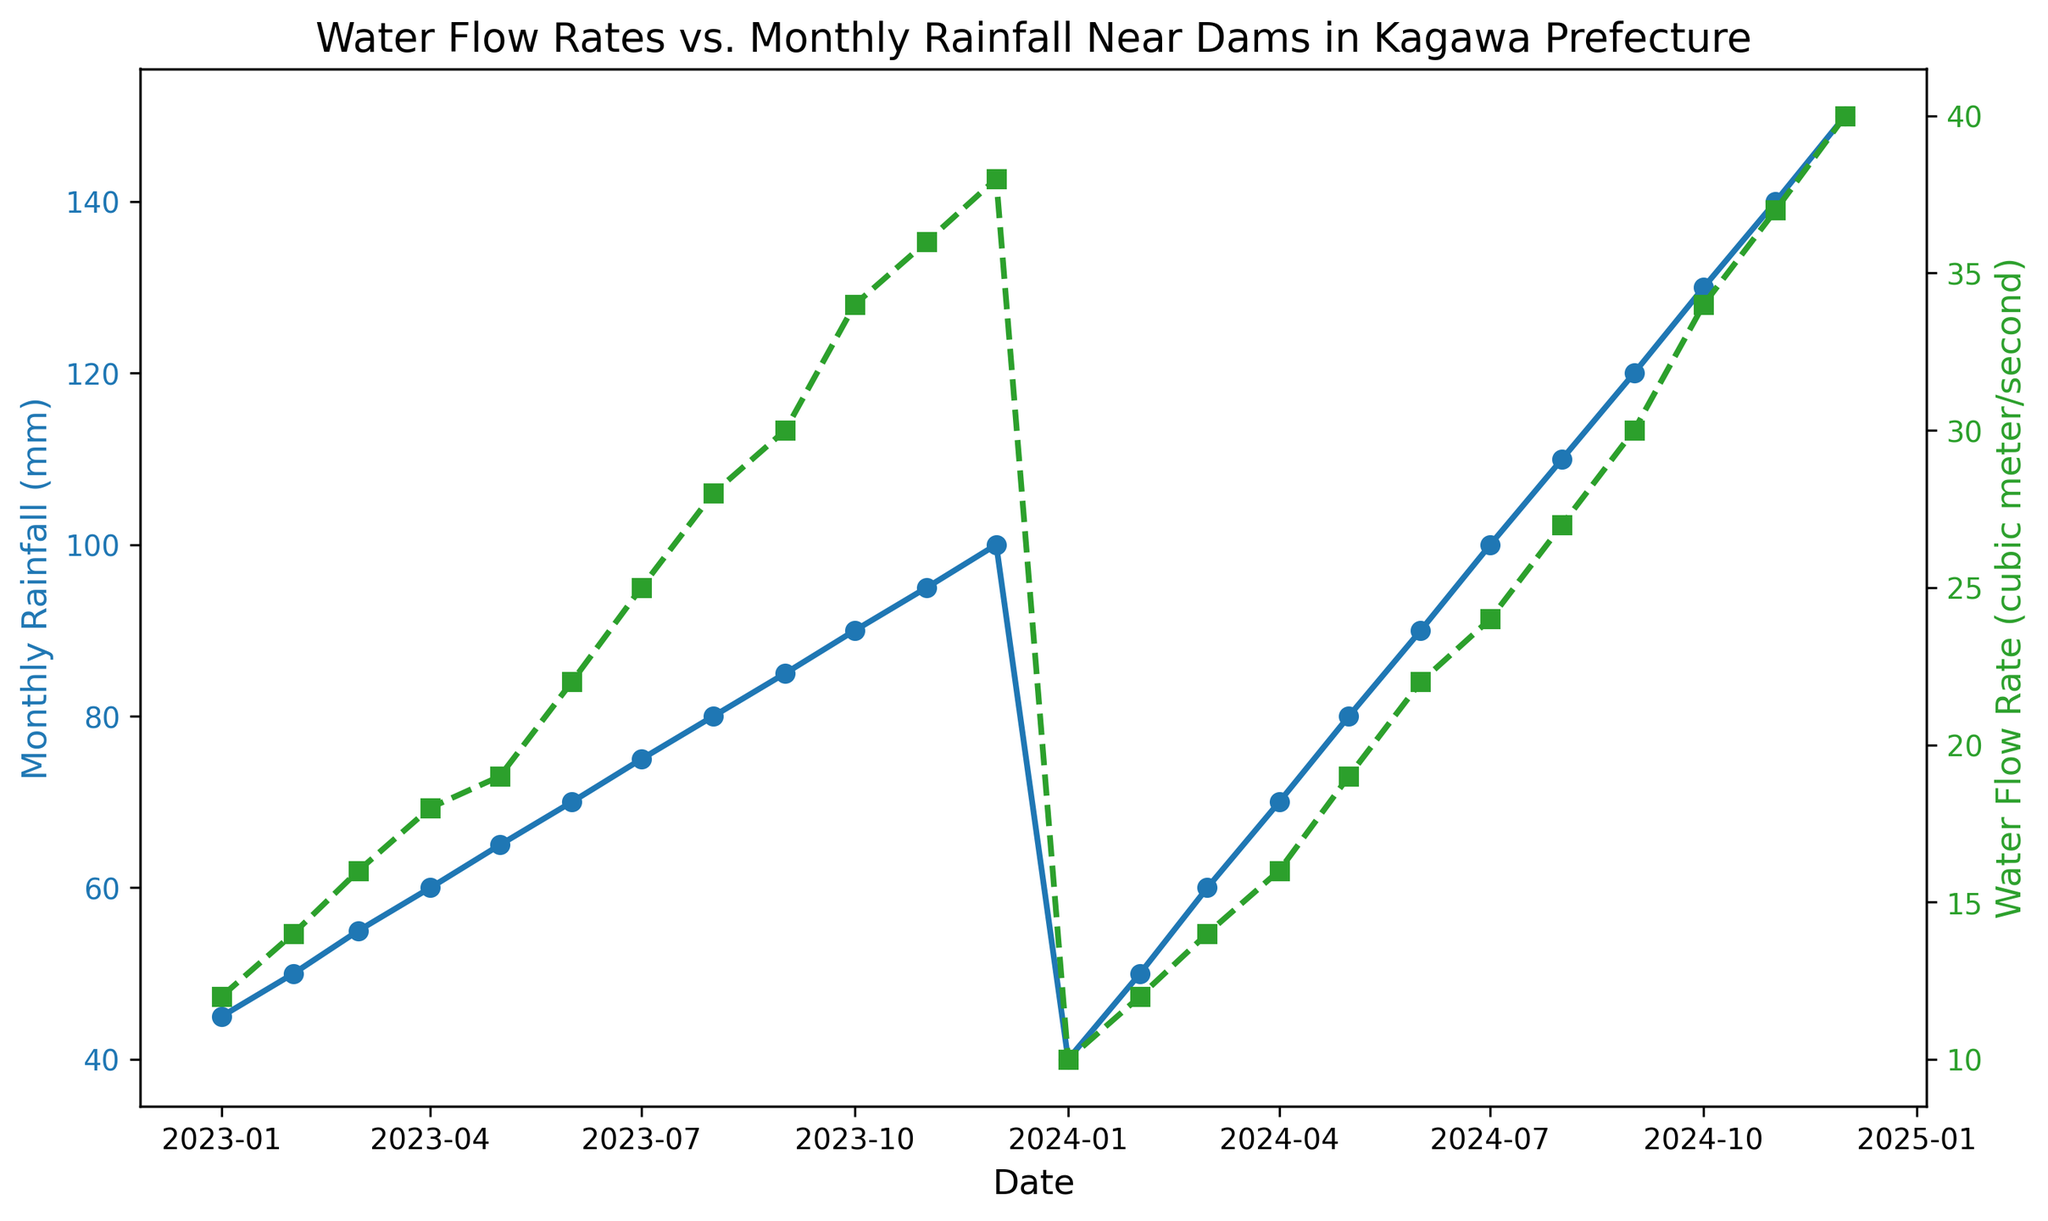What is the highest monthly rainfall recorded in the figure? Look at the data points in the blue line which represents the monthly rainfall. Identify the highest point in terms of Y-axis value, which corresponds to the number 150mm in December 2024.
Answer: 150mm What is the difference in water flow rate between January 2023 and December 2024? Identify the water flow rate in January 2023 (12 cubic meters/second) and December 2024 (40 cubic meters/second). Subtract the former from the latter: 40 - 12 = 28 cubic meters/second.
Answer: 28 cubic meters/second Between which two consecutive months does the water flow rate increase the most? Observe the green line (Water Flow Rate) and identify the steepest upward segment. The largest increase occurs between January 2024 (10 cubic meters/second) and February 2024 (12 cubic meters/second) with an increase of 2 cubic meters/second.
Answer: January 2024 to February 2024 How would you describe the general trend between monthly rainfall and water flow rate over time? Both lines (blue for rainfall and green for water flow rate) show an increasing trend. They generally rise together, suggesting a correlation where higher rainfall leads to higher water flow.
Answer: Increasing When does the water flow rate first reach 30 cubic meters/second? Check the green line (Water Flow Rate) and identify the first point it crosses the 30 cubic meters/second mark. This occurs in September 2023.
Answer: September 2023 What is the average monthly rainfall for the year 2023? Sum the monthly rainfall values for all months in 2023: 45 + 50 + 55 + 60 + 65 + 70 + 75 + 80 + 85 + 90 + 95 + 100 = 870 mm. Divide by 12 (months): 870 / 12 = 72.5 mm.
Answer: 72.5 mm Which month has the lowest water flow rate and what is it? Refer to the lowest point on the green line (Water Flow Rate). The lowest value is 10 cubic meters/second in January 2024.
Answer: January 2024, 10 cubic meters/second How much did the water flow rate increase from June 2023 to December 2023? Identify the water flow rate in June 2023 (22 cubic meters/second) and December 2023 (38 cubic meters/second). Subtract June's value from December’s: 38 - 22 = 16 cubic meters/second.
Answer: 16 cubic meters/second What is the relationship between the colors of the lines and the data they represent? The blue line represents Monthly Rainfall and the green line represents Water Flow Rate, with each color clearly distinguished for visual clarity.
Answer: Blue: Monthly Rainfall, Green: Water Flow Rate 